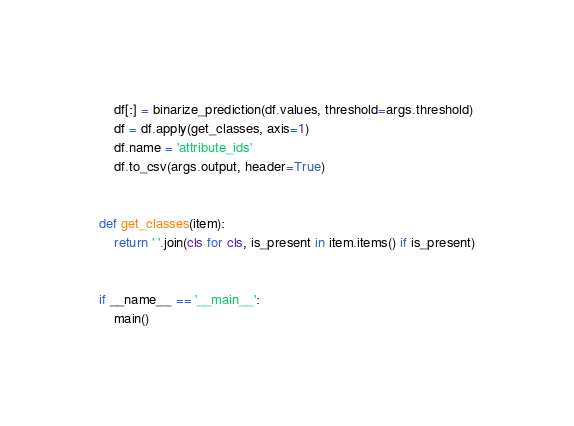<code> <loc_0><loc_0><loc_500><loc_500><_Python_>    df[:] = binarize_prediction(df.values, threshold=args.threshold)
    df = df.apply(get_classes, axis=1)
    df.name = 'attribute_ids'
    df.to_csv(args.output, header=True)


def get_classes(item):
    return ' '.join(cls for cls, is_present in item.items() if is_present)


if __name__ == '__main__':
    main()
</code> 